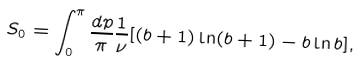<formula> <loc_0><loc_0><loc_500><loc_500>S _ { 0 } = \int _ { 0 } ^ { \pi } \frac { d p } { \pi } \frac { 1 } { \nu } [ ( b + 1 ) \ln ( b + 1 ) - b \ln b ] ,</formula> 